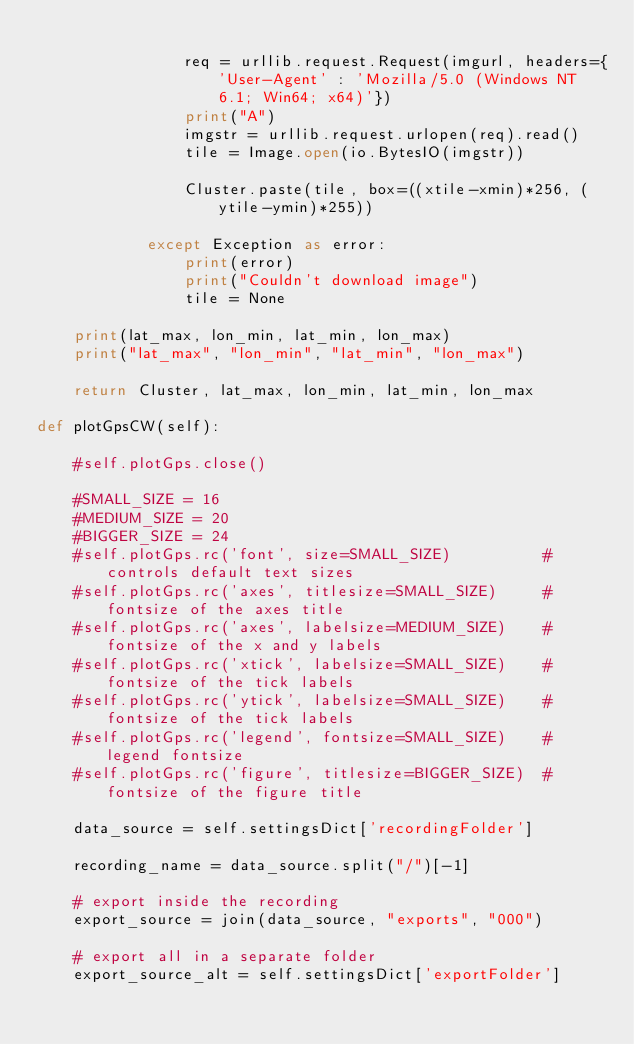<code> <loc_0><loc_0><loc_500><loc_500><_Python_>
                req = urllib.request.Request(imgurl, headers={'User-Agent' : 'Mozilla/5.0 (Windows NT 6.1; Win64; x64)'})
                print("A")
                imgstr = urllib.request.urlopen(req).read()
                tile = Image.open(io.BytesIO(imgstr))

                Cluster.paste(tile, box=((xtile-xmin)*256, (ytile-ymin)*255))

            except Exception as error:
                print(error)
                print("Couldn't download image")
                tile = None

    print(lat_max, lon_min, lat_min, lon_max)
    print("lat_max", "lon_min", "lat_min", "lon_max")

    return Cluster, lat_max, lon_min, lat_min, lon_max

def plotGpsCW(self):

    #self.plotGps.close()

    #SMALL_SIZE = 16
    #MEDIUM_SIZE = 20
    #BIGGER_SIZE = 24
    #self.plotGps.rc('font', size=SMALL_SIZE)          # controls default text sizes
    #self.plotGps.rc('axes', titlesize=SMALL_SIZE)     # fontsize of the axes title
    #self.plotGps.rc('axes', labelsize=MEDIUM_SIZE)    # fontsize of the x and y labels
    #self.plotGps.rc('xtick', labelsize=SMALL_SIZE)    # fontsize of the tick labels
    #self.plotGps.rc('ytick', labelsize=SMALL_SIZE)    # fontsize of the tick labels
    #self.plotGps.rc('legend', fontsize=SMALL_SIZE)    # legend fontsize
    #self.plotGps.rc('figure', titlesize=BIGGER_SIZE)  # fontsize of the figure title

    data_source = self.settingsDict['recordingFolder']

    recording_name = data_source.split("/")[-1]

    # export inside the recording
    export_source = join(data_source, "exports", "000")

    # export all in a separate folder
    export_source_alt = self.settingsDict['exportFolder']</code> 